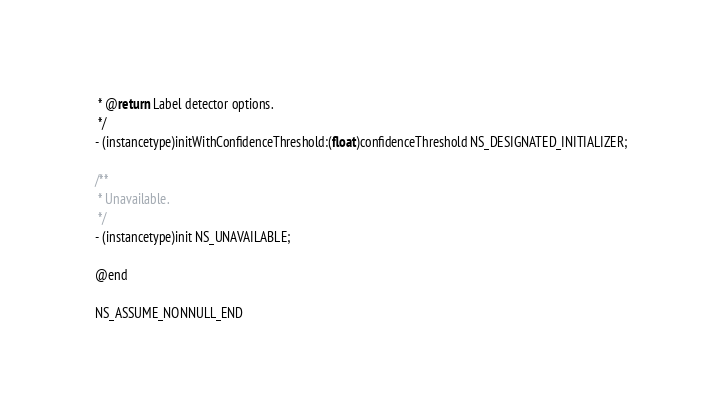<code> <loc_0><loc_0><loc_500><loc_500><_C_> * @return Label detector options.
 */
- (instancetype)initWithConfidenceThreshold:(float)confidenceThreshold NS_DESIGNATED_INITIALIZER;

/**
 * Unavailable.
 */
- (instancetype)init NS_UNAVAILABLE;

@end

NS_ASSUME_NONNULL_END
</code> 